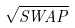<formula> <loc_0><loc_0><loc_500><loc_500>\sqrt { S W A P }</formula> 